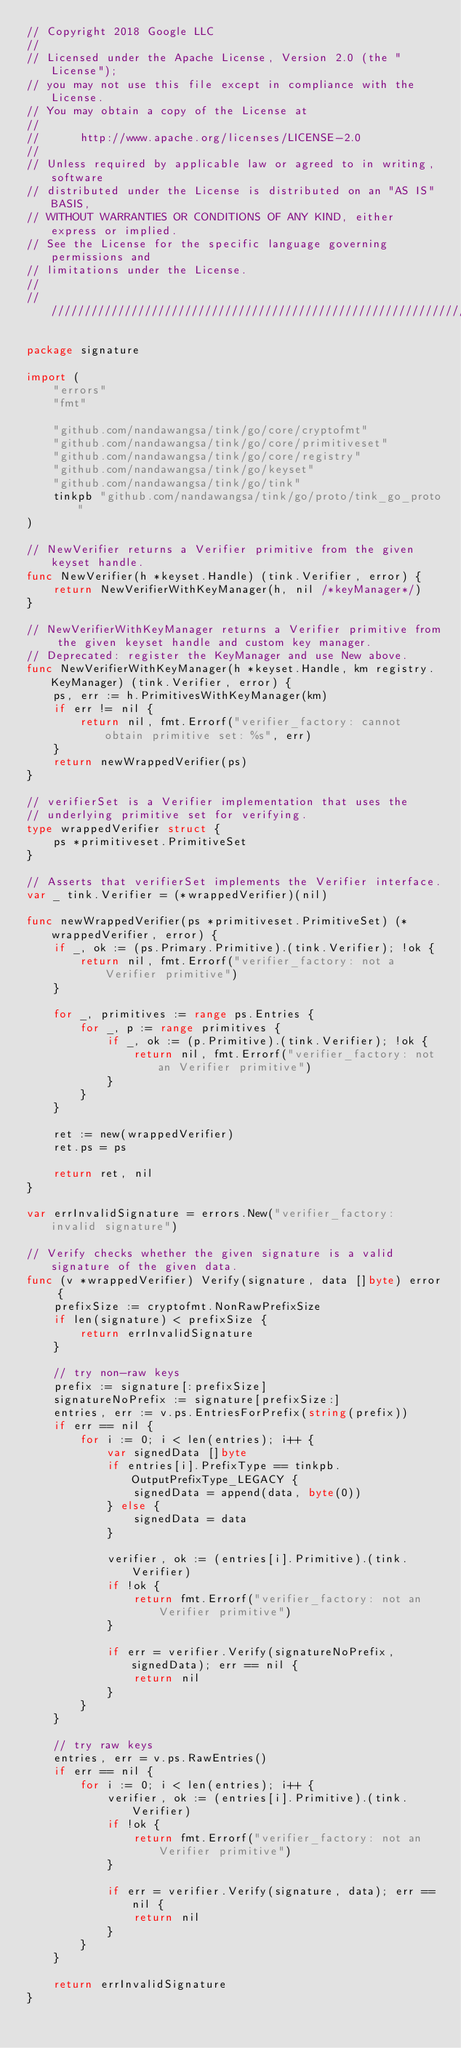Convert code to text. <code><loc_0><loc_0><loc_500><loc_500><_Go_>// Copyright 2018 Google LLC
//
// Licensed under the Apache License, Version 2.0 (the "License");
// you may not use this file except in compliance with the License.
// You may obtain a copy of the License at
//
//      http://www.apache.org/licenses/LICENSE-2.0
//
// Unless required by applicable law or agreed to in writing, software
// distributed under the License is distributed on an "AS IS" BASIS,
// WITHOUT WARRANTIES OR CONDITIONS OF ANY KIND, either express or implied.
// See the License for the specific language governing permissions and
// limitations under the License.
//
////////////////////////////////////////////////////////////////////////////////

package signature

import (
	"errors"
	"fmt"

	"github.com/nandawangsa/tink/go/core/cryptofmt"
	"github.com/nandawangsa/tink/go/core/primitiveset"
	"github.com/nandawangsa/tink/go/core/registry"
	"github.com/nandawangsa/tink/go/keyset"
	"github.com/nandawangsa/tink/go/tink"
	tinkpb "github.com/nandawangsa/tink/go/proto/tink_go_proto"
)

// NewVerifier returns a Verifier primitive from the given keyset handle.
func NewVerifier(h *keyset.Handle) (tink.Verifier, error) {
	return NewVerifierWithKeyManager(h, nil /*keyManager*/)
}

// NewVerifierWithKeyManager returns a Verifier primitive from the given keyset handle and custom key manager.
// Deprecated: register the KeyManager and use New above.
func NewVerifierWithKeyManager(h *keyset.Handle, km registry.KeyManager) (tink.Verifier, error) {
	ps, err := h.PrimitivesWithKeyManager(km)
	if err != nil {
		return nil, fmt.Errorf("verifier_factory: cannot obtain primitive set: %s", err)
	}
	return newWrappedVerifier(ps)
}

// verifierSet is a Verifier implementation that uses the
// underlying primitive set for verifying.
type wrappedVerifier struct {
	ps *primitiveset.PrimitiveSet
}

// Asserts that verifierSet implements the Verifier interface.
var _ tink.Verifier = (*wrappedVerifier)(nil)

func newWrappedVerifier(ps *primitiveset.PrimitiveSet) (*wrappedVerifier, error) {
	if _, ok := (ps.Primary.Primitive).(tink.Verifier); !ok {
		return nil, fmt.Errorf("verifier_factory: not a Verifier primitive")
	}

	for _, primitives := range ps.Entries {
		for _, p := range primitives {
			if _, ok := (p.Primitive).(tink.Verifier); !ok {
				return nil, fmt.Errorf("verifier_factory: not an Verifier primitive")
			}
		}
	}

	ret := new(wrappedVerifier)
	ret.ps = ps

	return ret, nil
}

var errInvalidSignature = errors.New("verifier_factory: invalid signature")

// Verify checks whether the given signature is a valid signature of the given data.
func (v *wrappedVerifier) Verify(signature, data []byte) error {
	prefixSize := cryptofmt.NonRawPrefixSize
	if len(signature) < prefixSize {
		return errInvalidSignature
	}

	// try non-raw keys
	prefix := signature[:prefixSize]
	signatureNoPrefix := signature[prefixSize:]
	entries, err := v.ps.EntriesForPrefix(string(prefix))
	if err == nil {
		for i := 0; i < len(entries); i++ {
			var signedData []byte
			if entries[i].PrefixType == tinkpb.OutputPrefixType_LEGACY {
				signedData = append(data, byte(0))
			} else {
				signedData = data
			}

			verifier, ok := (entries[i].Primitive).(tink.Verifier)
			if !ok {
				return fmt.Errorf("verifier_factory: not an Verifier primitive")
			}

			if err = verifier.Verify(signatureNoPrefix, signedData); err == nil {
				return nil
			}
		}
	}

	// try raw keys
	entries, err = v.ps.RawEntries()
	if err == nil {
		for i := 0; i < len(entries); i++ {
			verifier, ok := (entries[i].Primitive).(tink.Verifier)
			if !ok {
				return fmt.Errorf("verifier_factory: not an Verifier primitive")
			}

			if err = verifier.Verify(signature, data); err == nil {
				return nil
			}
		}
	}

	return errInvalidSignature
}
</code> 